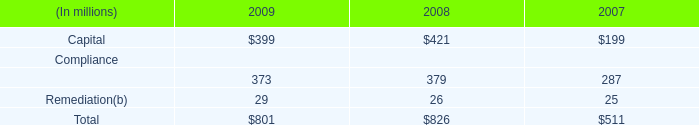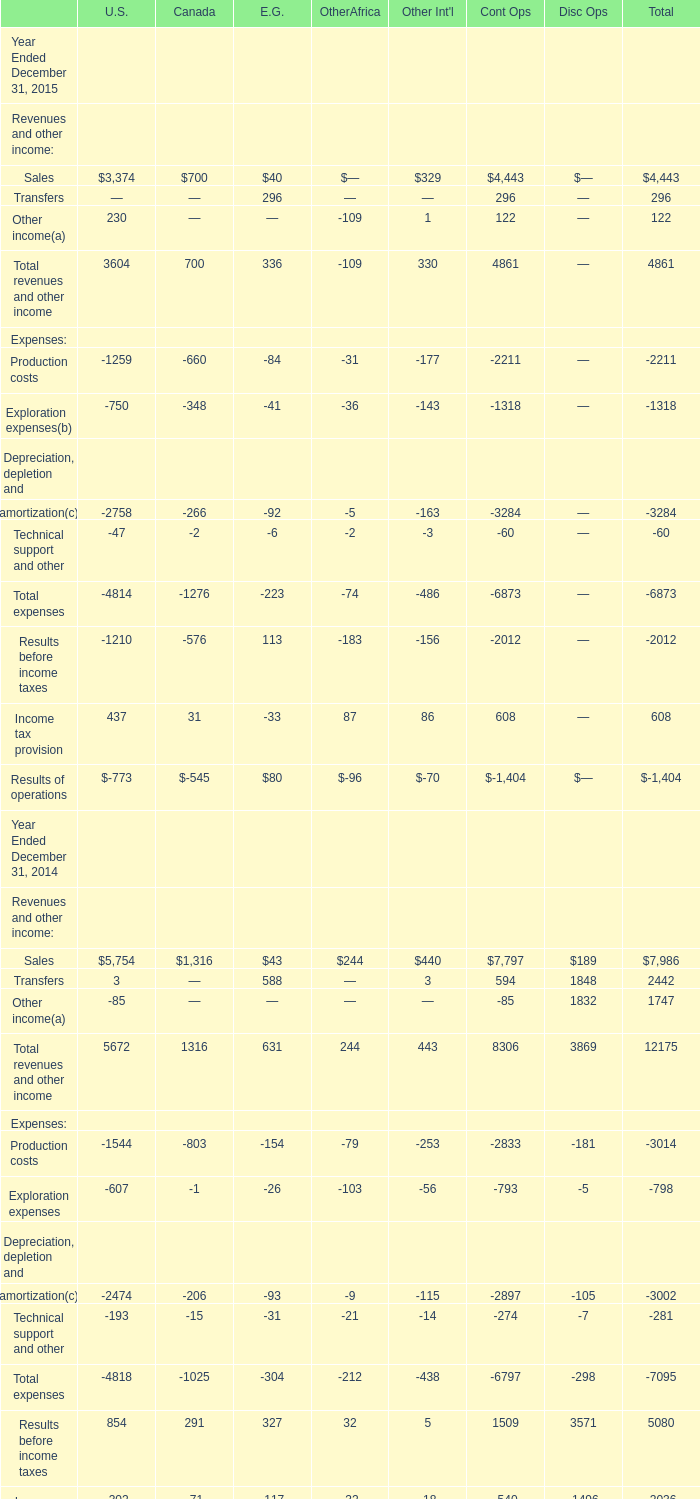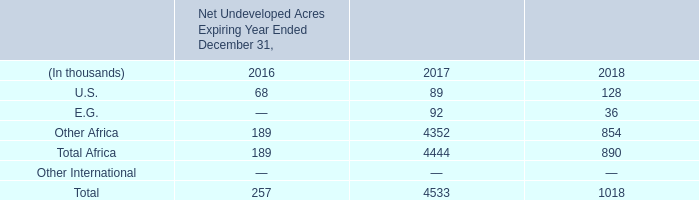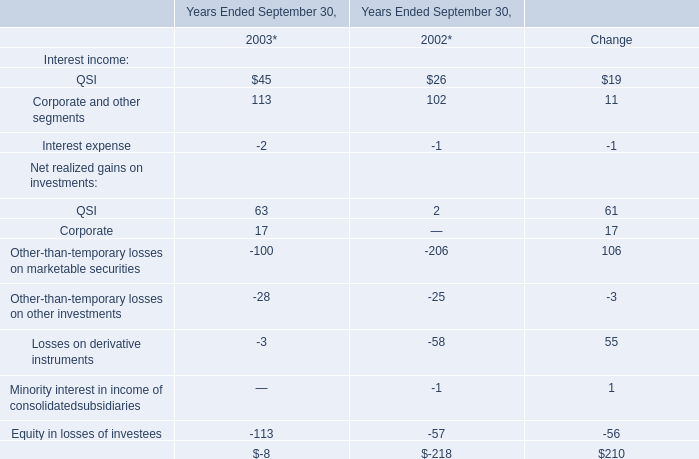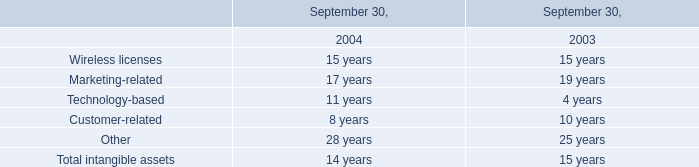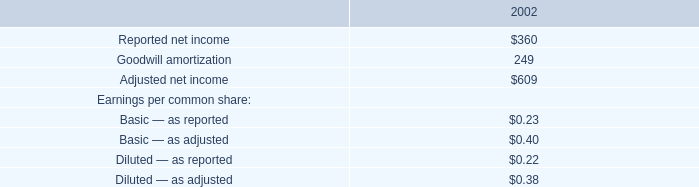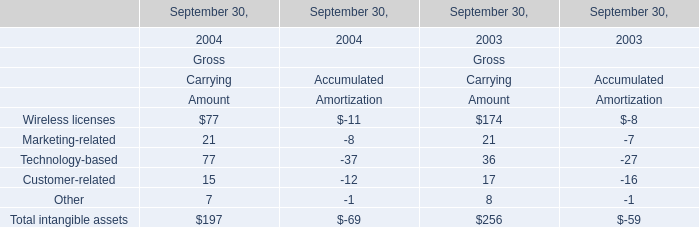What was the total amount of the Revenues and other income:Transfers for U.S. in the years where Revenues and other income: Sales is greater than 5000 for U.S.? 
Computations: (3 + 3)
Answer: 6.0. 